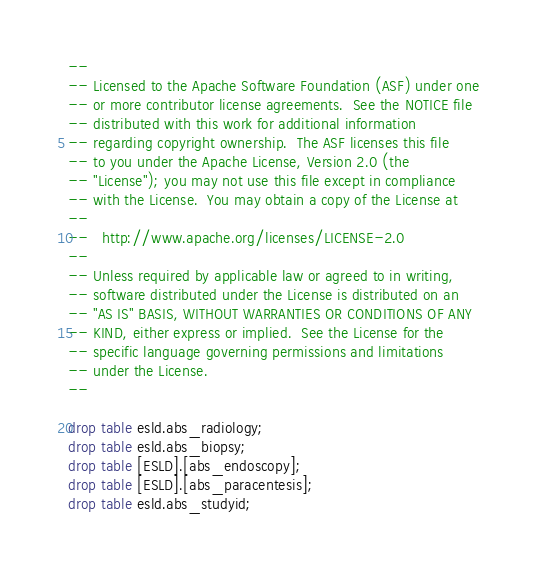<code> <loc_0><loc_0><loc_500><loc_500><_SQL_>--
-- Licensed to the Apache Software Foundation (ASF) under one
-- or more contributor license agreements.  See the NOTICE file
-- distributed with this work for additional information
-- regarding copyright ownership.  The ASF licenses this file
-- to you under the Apache License, Version 2.0 (the
-- "License"); you may not use this file except in compliance
-- with the License.  You may obtain a copy of the License at
--
--   http://www.apache.org/licenses/LICENSE-2.0
--
-- Unless required by applicable law or agreed to in writing,
-- software distributed under the License is distributed on an
-- "AS IS" BASIS, WITHOUT WARRANTIES OR CONDITIONS OF ANY
-- KIND, either express or implied.  See the License for the
-- specific language governing permissions and limitations
-- under the License.
--

drop table esld.abs_radiology;
drop table esld.abs_biopsy;
drop table [ESLD].[abs_endoscopy];
drop table [ESLD].[abs_paracentesis];
drop table esld.abs_studyid;</code> 